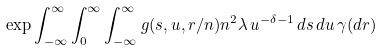<formula> <loc_0><loc_0><loc_500><loc_500>\exp \int _ { - \infty } ^ { \infty } \int _ { 0 } ^ { \infty } \int _ { - \infty } ^ { \infty } g ( s , u , r / n ) n ^ { 2 } \lambda \, u ^ { - \delta - 1 } \, d s \, d u \, \gamma ( d r )</formula> 